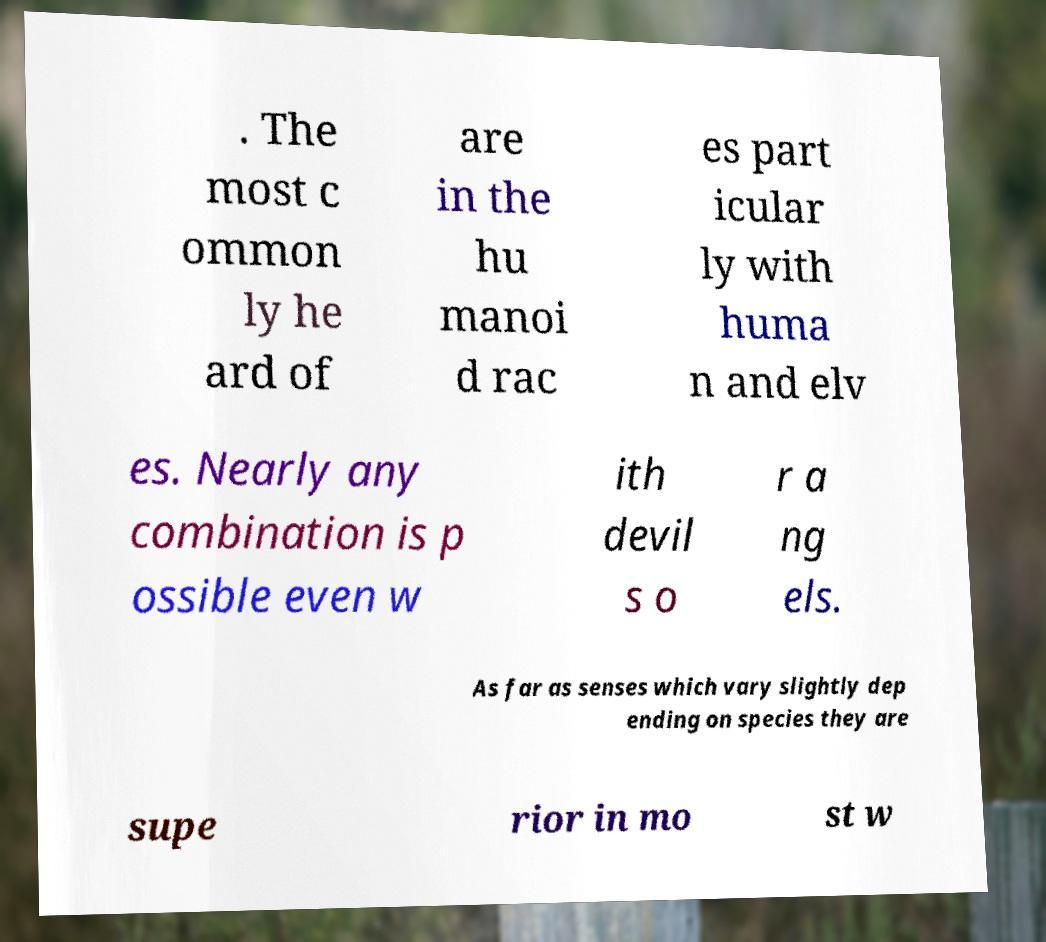There's text embedded in this image that I need extracted. Can you transcribe it verbatim? . The most c ommon ly he ard of are in the hu manoi d rac es part icular ly with huma n and elv es. Nearly any combination is p ossible even w ith devil s o r a ng els. As far as senses which vary slightly dep ending on species they are supe rior in mo st w 